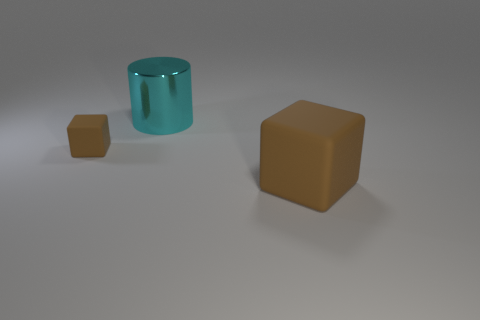What could be the function of the cylindrical object in the image? Given the simplicity of the image and the lack of additional context, it is difficult to determine a specific function for the cylindrical object. However, its shape is reminiscent of containers or storage vessels, which suggests that, in a real-world setting, it could serve as a holder for various items. 